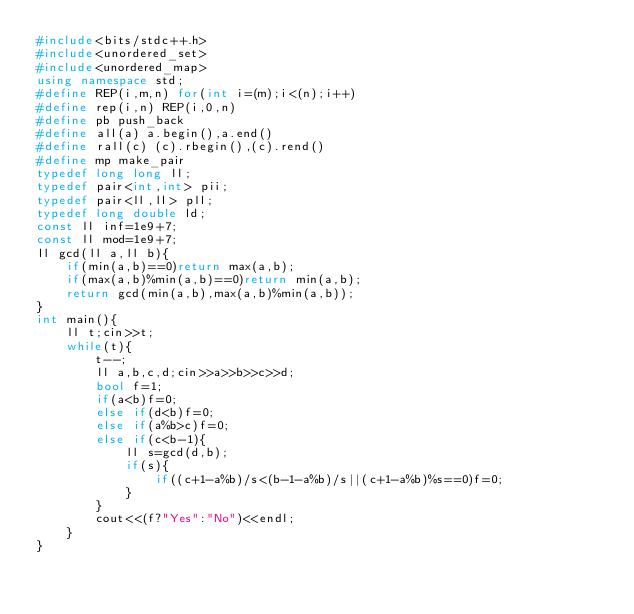<code> <loc_0><loc_0><loc_500><loc_500><_C++_>#include<bits/stdc++.h>
#include<unordered_set>
#include<unordered_map>
using namespace std;
#define REP(i,m,n) for(int i=(m);i<(n);i++)
#define rep(i,n) REP(i,0,n)
#define pb push_back
#define all(a) a.begin(),a.end()
#define rall(c) (c).rbegin(),(c).rend()
#define mp make_pair
typedef long long ll;
typedef pair<int,int> pii;
typedef pair<ll,ll> pll;
typedef long double ld;
const ll inf=1e9+7;
const ll mod=1e9+7;
ll gcd(ll a,ll b){
    if(min(a,b)==0)return max(a,b);
    if(max(a,b)%min(a,b)==0)return min(a,b);
    return gcd(min(a,b),max(a,b)%min(a,b));
}
int main(){
    ll t;cin>>t;
    while(t){
        t--;
        ll a,b,c,d;cin>>a>>b>>c>>d;
        bool f=1;
        if(a<b)f=0;
        else if(d<b)f=0;
        else if(a%b>c)f=0;
        else if(c<b-1){
            ll s=gcd(d,b);
            if(s){
                if((c+1-a%b)/s<(b-1-a%b)/s||(c+1-a%b)%s==0)f=0;
            }
        }
        cout<<(f?"Yes":"No")<<endl;
    }
}</code> 